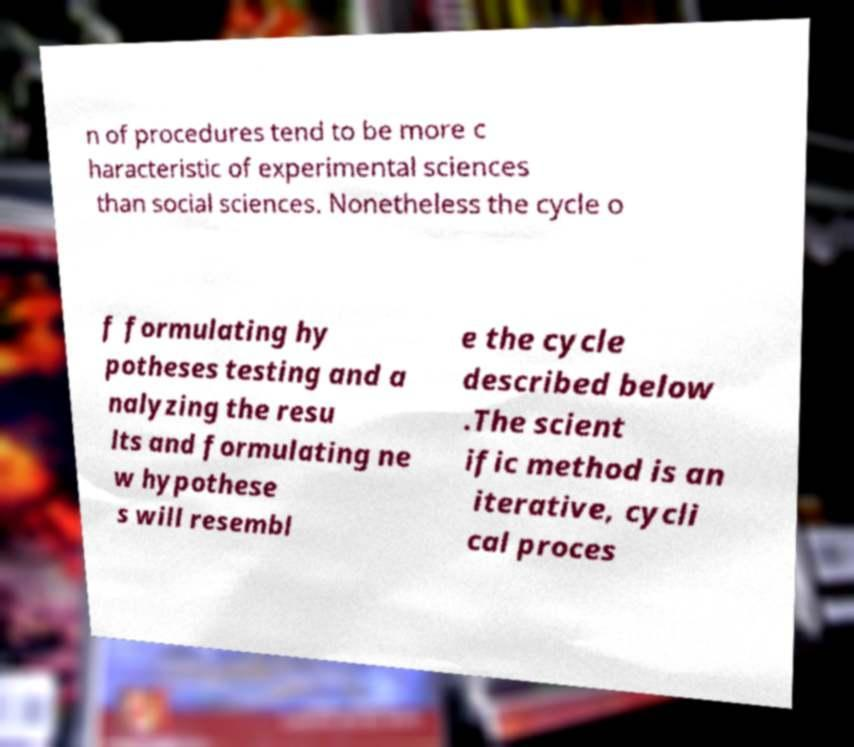Please identify and transcribe the text found in this image. n of procedures tend to be more c haracteristic of experimental sciences than social sciences. Nonetheless the cycle o f formulating hy potheses testing and a nalyzing the resu lts and formulating ne w hypothese s will resembl e the cycle described below .The scient ific method is an iterative, cycli cal proces 